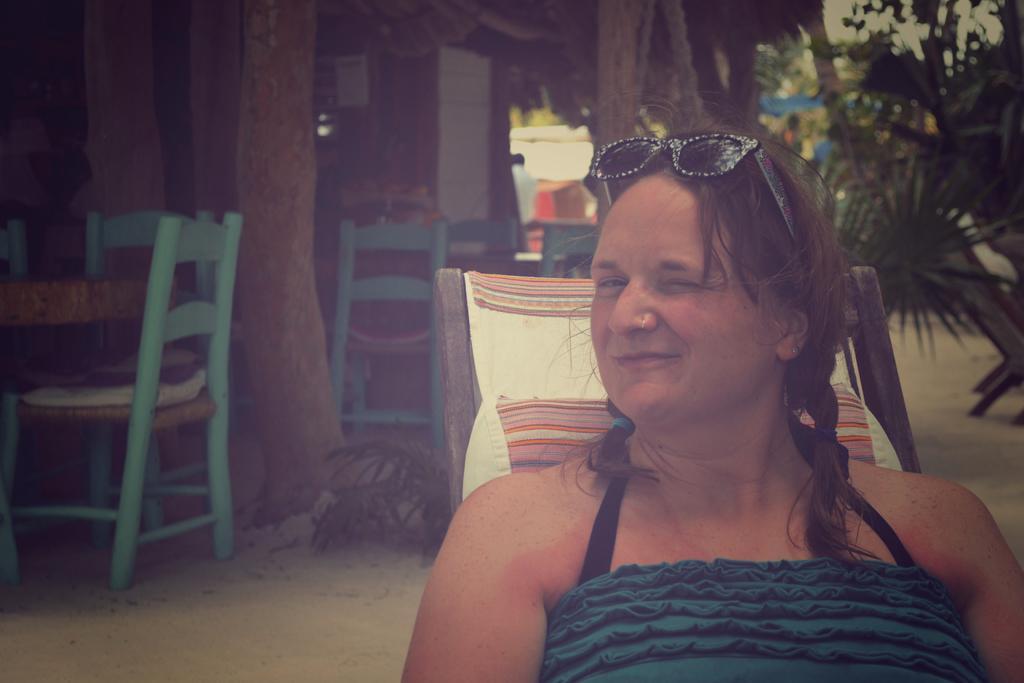Could you give a brief overview of what you see in this image? In this image there is a woman sitting and smiling in a chair , at the back ground there are chairs, tables, trees, buildings, sky. 